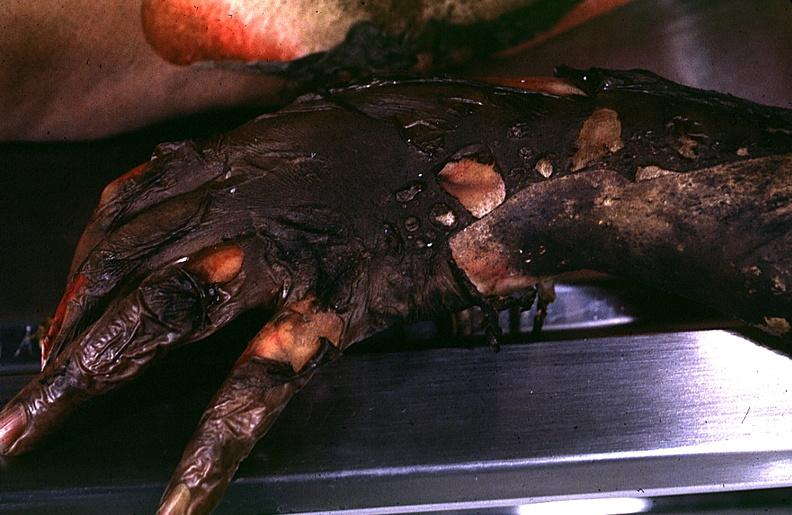does yellow color show thermal burn?
Answer the question using a single word or phrase. No 